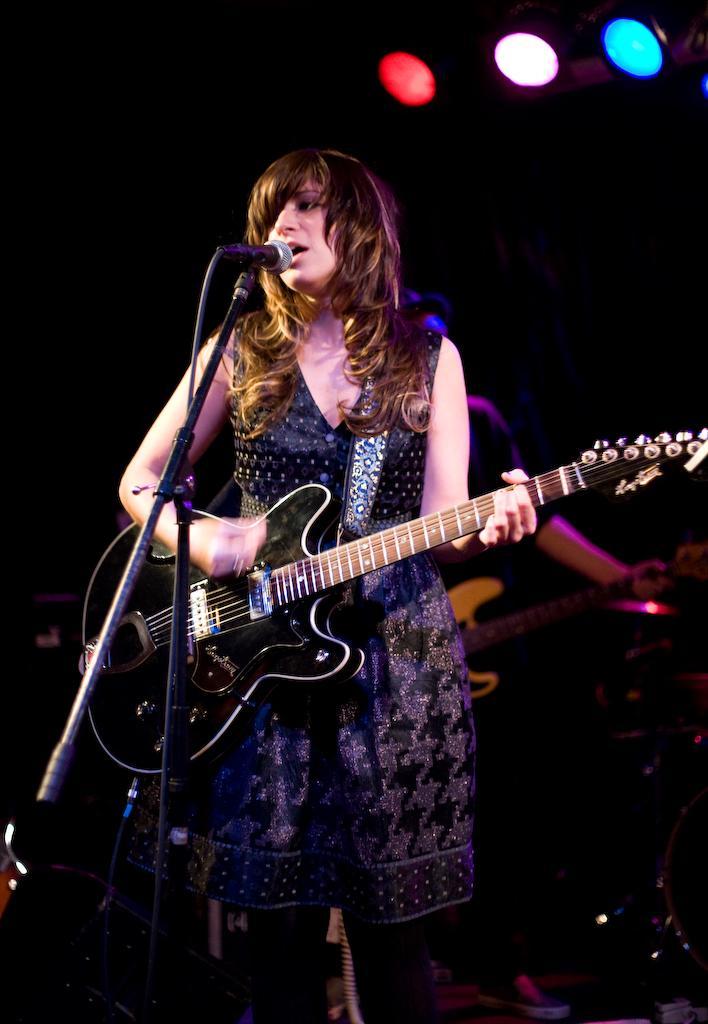Describe this image in one or two sentences. A lady with black frock she is playing a guitar. In front of her there is a mic. At the back of her there is another person playing a guitar. 